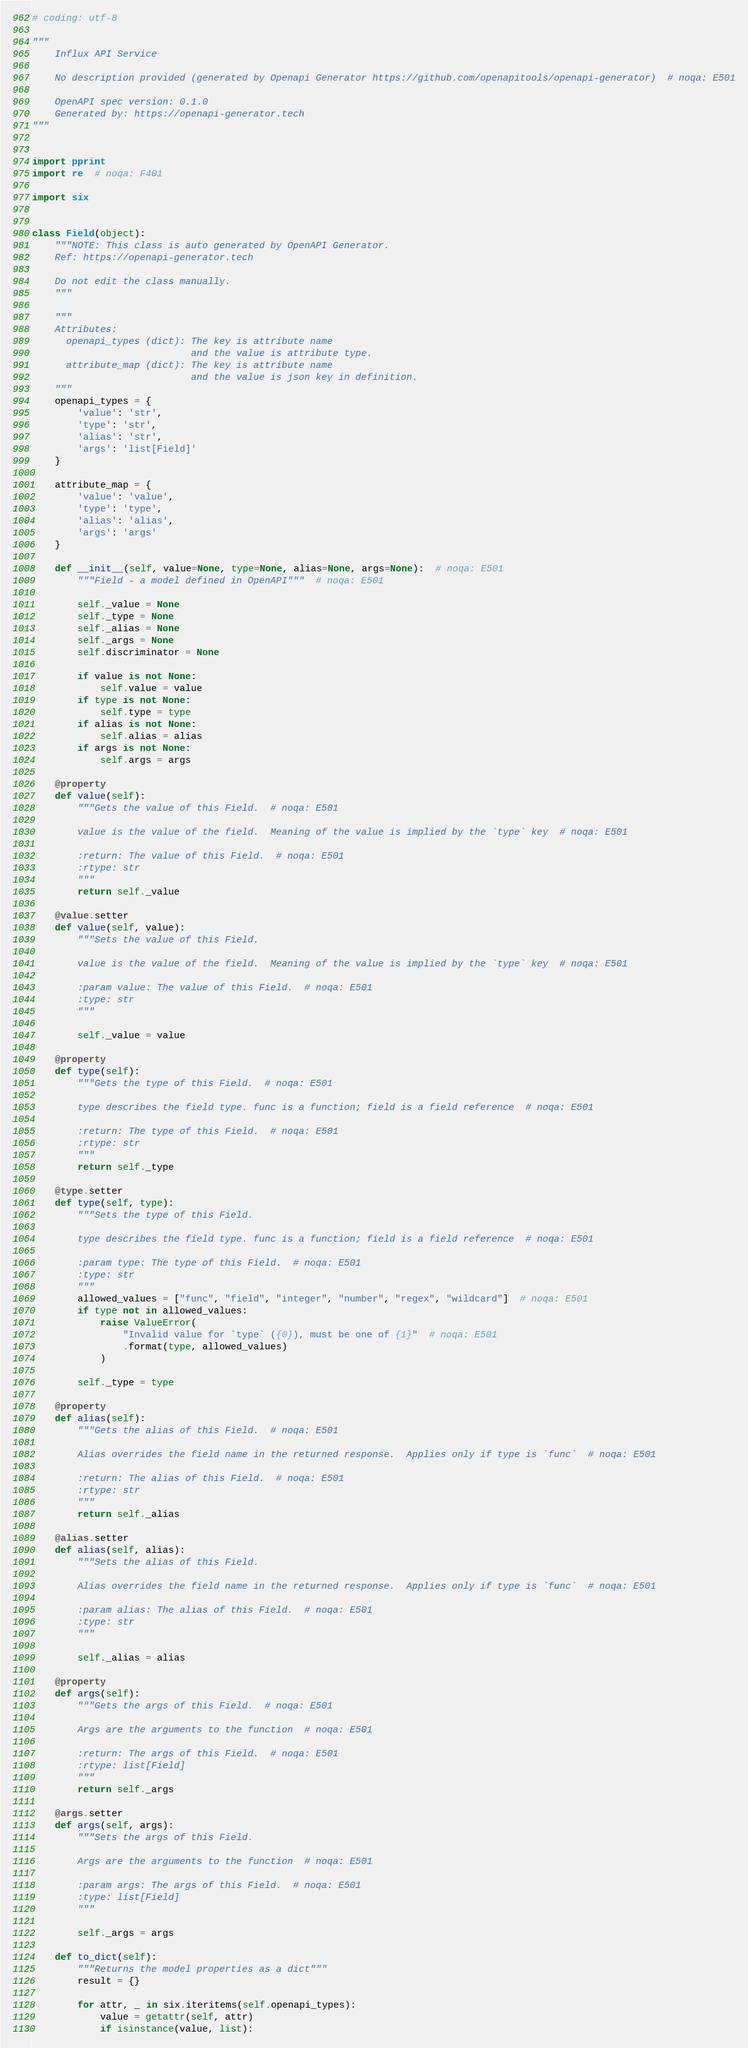Convert code to text. <code><loc_0><loc_0><loc_500><loc_500><_Python_># coding: utf-8

"""
    Influx API Service

    No description provided (generated by Openapi Generator https://github.com/openapitools/openapi-generator)  # noqa: E501

    OpenAPI spec version: 0.1.0
    Generated by: https://openapi-generator.tech
"""


import pprint
import re  # noqa: F401

import six


class Field(object):
    """NOTE: This class is auto generated by OpenAPI Generator.
    Ref: https://openapi-generator.tech

    Do not edit the class manually.
    """

    """
    Attributes:
      openapi_types (dict): The key is attribute name
                            and the value is attribute type.
      attribute_map (dict): The key is attribute name
                            and the value is json key in definition.
    """
    openapi_types = {
        'value': 'str',
        'type': 'str',
        'alias': 'str',
        'args': 'list[Field]'
    }

    attribute_map = {
        'value': 'value',
        'type': 'type',
        'alias': 'alias',
        'args': 'args'
    }

    def __init__(self, value=None, type=None, alias=None, args=None):  # noqa: E501
        """Field - a model defined in OpenAPI"""  # noqa: E501

        self._value = None
        self._type = None
        self._alias = None
        self._args = None
        self.discriminator = None

        if value is not None:
            self.value = value
        if type is not None:
            self.type = type
        if alias is not None:
            self.alias = alias
        if args is not None:
            self.args = args

    @property
    def value(self):
        """Gets the value of this Field.  # noqa: E501

        value is the value of the field.  Meaning of the value is implied by the `type` key  # noqa: E501

        :return: The value of this Field.  # noqa: E501
        :rtype: str
        """
        return self._value

    @value.setter
    def value(self, value):
        """Sets the value of this Field.

        value is the value of the field.  Meaning of the value is implied by the `type` key  # noqa: E501

        :param value: The value of this Field.  # noqa: E501
        :type: str
        """

        self._value = value

    @property
    def type(self):
        """Gets the type of this Field.  # noqa: E501

        type describes the field type. func is a function; field is a field reference  # noqa: E501

        :return: The type of this Field.  # noqa: E501
        :rtype: str
        """
        return self._type

    @type.setter
    def type(self, type):
        """Sets the type of this Field.

        type describes the field type. func is a function; field is a field reference  # noqa: E501

        :param type: The type of this Field.  # noqa: E501
        :type: str
        """
        allowed_values = ["func", "field", "integer", "number", "regex", "wildcard"]  # noqa: E501
        if type not in allowed_values:
            raise ValueError(
                "Invalid value for `type` ({0}), must be one of {1}"  # noqa: E501
                .format(type, allowed_values)
            )

        self._type = type

    @property
    def alias(self):
        """Gets the alias of this Field.  # noqa: E501

        Alias overrides the field name in the returned response.  Applies only if type is `func`  # noqa: E501

        :return: The alias of this Field.  # noqa: E501
        :rtype: str
        """
        return self._alias

    @alias.setter
    def alias(self, alias):
        """Sets the alias of this Field.

        Alias overrides the field name in the returned response.  Applies only if type is `func`  # noqa: E501

        :param alias: The alias of this Field.  # noqa: E501
        :type: str
        """

        self._alias = alias

    @property
    def args(self):
        """Gets the args of this Field.  # noqa: E501

        Args are the arguments to the function  # noqa: E501

        :return: The args of this Field.  # noqa: E501
        :rtype: list[Field]
        """
        return self._args

    @args.setter
    def args(self, args):
        """Sets the args of this Field.

        Args are the arguments to the function  # noqa: E501

        :param args: The args of this Field.  # noqa: E501
        :type: list[Field]
        """

        self._args = args

    def to_dict(self):
        """Returns the model properties as a dict"""
        result = {}

        for attr, _ in six.iteritems(self.openapi_types):
            value = getattr(self, attr)
            if isinstance(value, list):</code> 